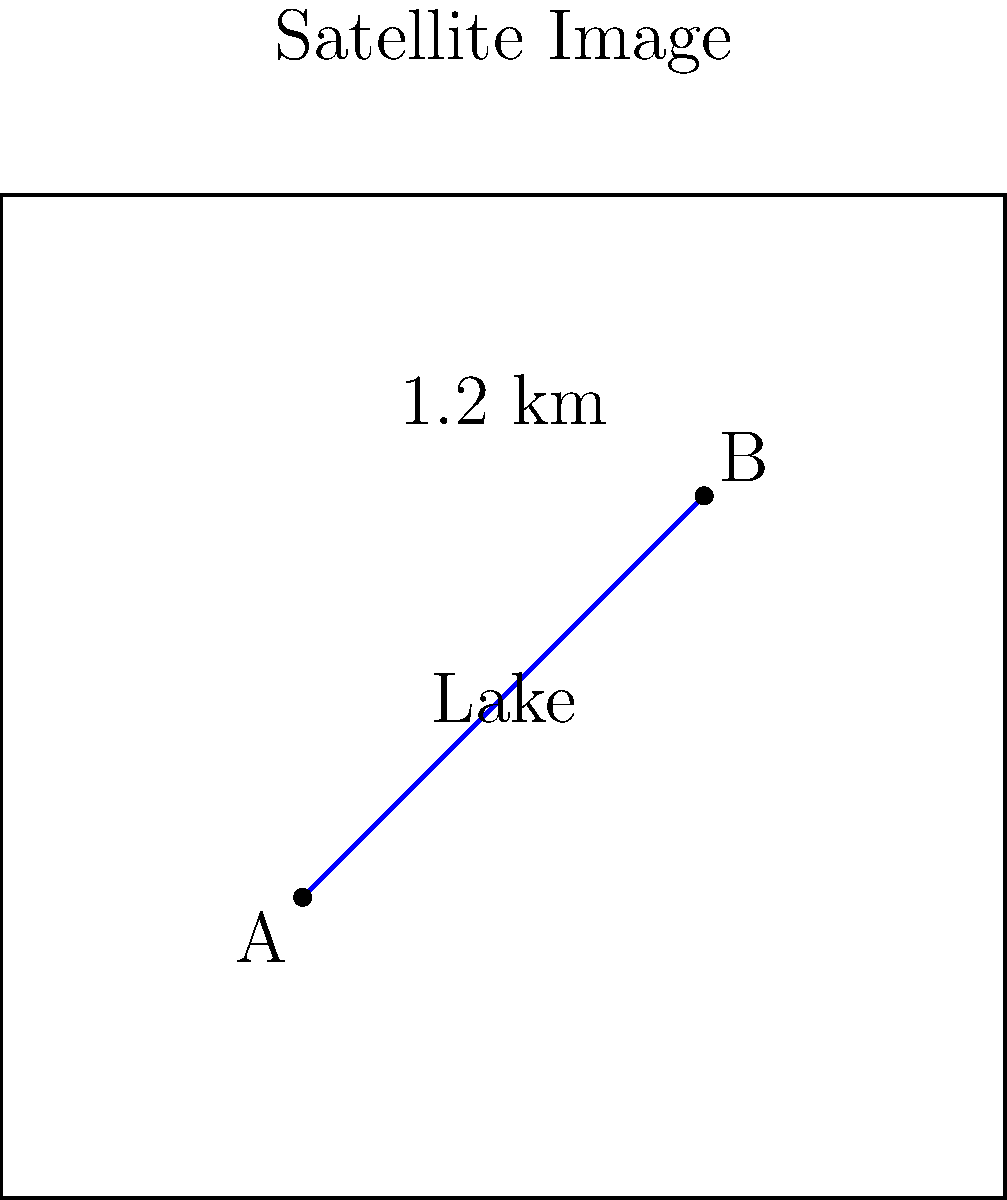In a satellite image of a remote ecosystem, a linear feature (such as a road or river) is measured to be 2.4 cm long. This feature is known to be 1.2 km long in reality. What is the scale of this satellite image? To determine the scale of the satellite image, we need to compare the measured length on the image to the actual length on the ground. Here's how we can calculate it:

1. Given information:
   - Image measurement: 2.4 cm
   - Actual ground distance: 1.2 km

2. Convert the actual ground distance to centimeters:
   1.2 km = 1.2 × 1000 m = 120,000 cm

3. Set up the scale ratio:
   Scale = Image distance : Ground distance
   Scale = 2.4 cm : 120,000 cm

4. Simplify the ratio:
   $\frac{2.4}{120,000} = \frac{1}{50,000}$

5. Express the scale in the standard format:
   1:50,000

This means that 1 cm on the image represents 50,000 cm (or 500 m) on the ground.
Answer: 1:50,000 